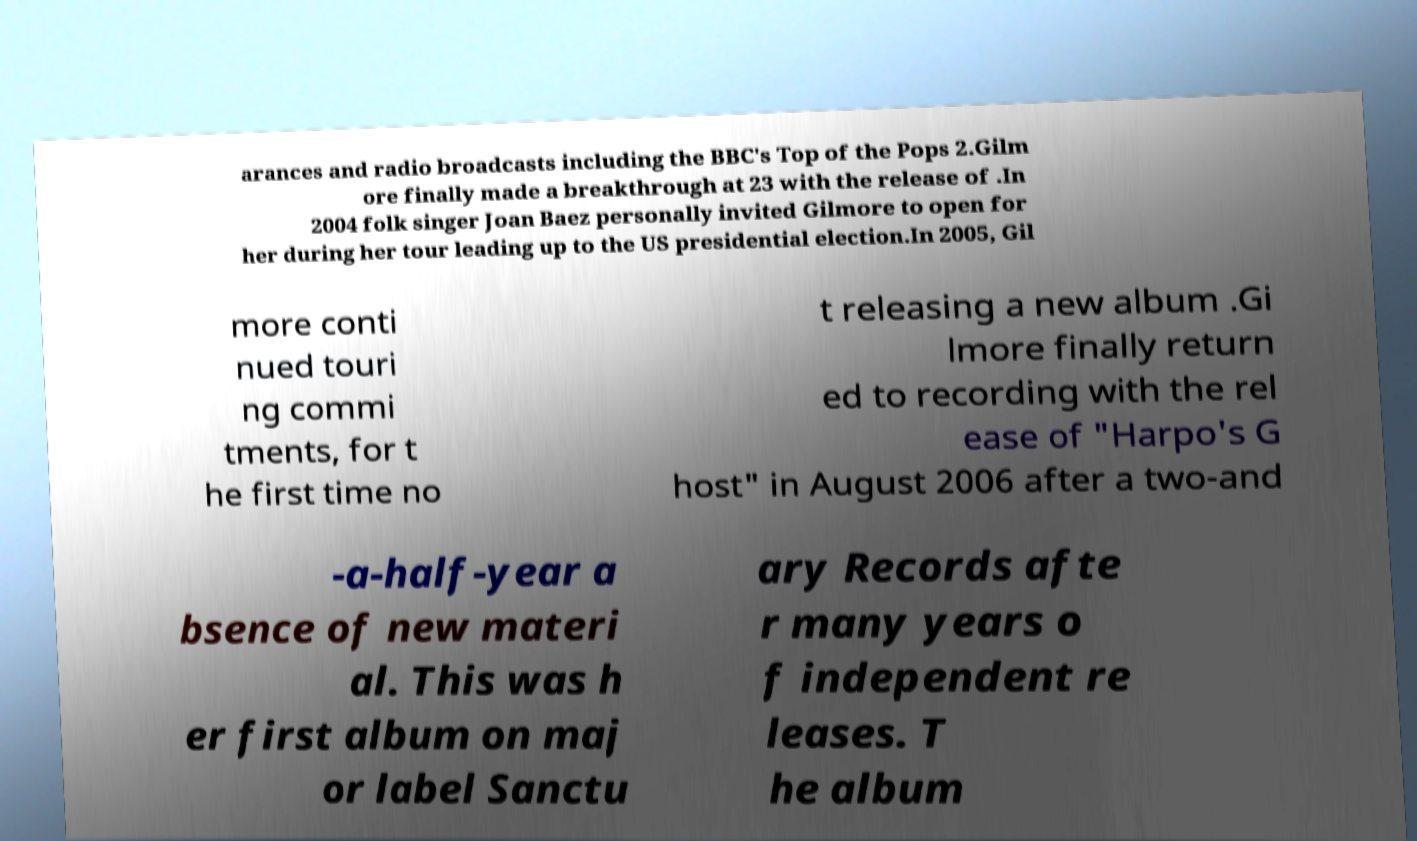There's text embedded in this image that I need extracted. Can you transcribe it verbatim? arances and radio broadcasts including the BBC's Top of the Pops 2.Gilm ore finally made a breakthrough at 23 with the release of .In 2004 folk singer Joan Baez personally invited Gilmore to open for her during her tour leading up to the US presidential election.In 2005, Gil more conti nued touri ng commi tments, for t he first time no t releasing a new album .Gi lmore finally return ed to recording with the rel ease of "Harpo's G host" in August 2006 after a two-and -a-half-year a bsence of new materi al. This was h er first album on maj or label Sanctu ary Records afte r many years o f independent re leases. T he album 